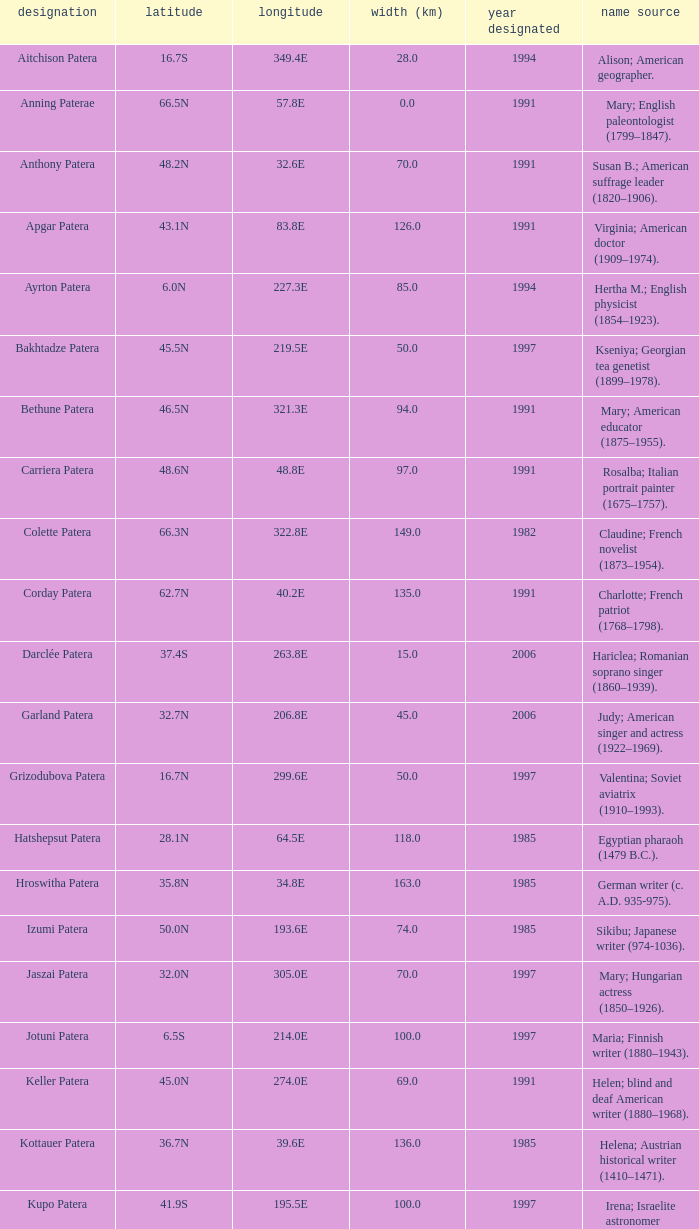Parse the table in full. {'header': ['designation', 'latitude', 'longitude', 'width (km)', 'year designated', 'name source'], 'rows': [['Aitchison Patera', '16.7S', '349.4E', '28.0', '1994', 'Alison; American geographer.'], ['Anning Paterae', '66.5N', '57.8E', '0.0', '1991', 'Mary; English paleontologist (1799–1847).'], ['Anthony Patera', '48.2N', '32.6E', '70.0', '1991', 'Susan B.; American suffrage leader (1820–1906).'], ['Apgar Patera', '43.1N', '83.8E', '126.0', '1991', 'Virginia; American doctor (1909–1974).'], ['Ayrton Patera', '6.0N', '227.3E', '85.0', '1994', 'Hertha M.; English physicist (1854–1923).'], ['Bakhtadze Patera', '45.5N', '219.5E', '50.0', '1997', 'Kseniya; Georgian tea genetist (1899–1978).'], ['Bethune Patera', '46.5N', '321.3E', '94.0', '1991', 'Mary; American educator (1875–1955).'], ['Carriera Patera', '48.6N', '48.8E', '97.0', '1991', 'Rosalba; Italian portrait painter (1675–1757).'], ['Colette Patera', '66.3N', '322.8E', '149.0', '1982', 'Claudine; French novelist (1873–1954).'], ['Corday Patera', '62.7N', '40.2E', '135.0', '1991', 'Charlotte; French patriot (1768–1798).'], ['Darclée Patera', '37.4S', '263.8E', '15.0', '2006', 'Hariclea; Romanian soprano singer (1860–1939).'], ['Garland Patera', '32.7N', '206.8E', '45.0', '2006', 'Judy; American singer and actress (1922–1969).'], ['Grizodubova Patera', '16.7N', '299.6E', '50.0', '1997', 'Valentina; Soviet aviatrix (1910–1993).'], ['Hatshepsut Patera', '28.1N', '64.5E', '118.0', '1985', 'Egyptian pharaoh (1479 B.C.).'], ['Hroswitha Patera', '35.8N', '34.8E', '163.0', '1985', 'German writer (c. A.D. 935-975).'], ['Izumi Patera', '50.0N', '193.6E', '74.0', '1985', 'Sikibu; Japanese writer (974-1036).'], ['Jaszai Patera', '32.0N', '305.0E', '70.0', '1997', 'Mary; Hungarian actress (1850–1926).'], ['Jotuni Patera', '6.5S', '214.0E', '100.0', '1997', 'Maria; Finnish writer (1880–1943).'], ['Keller Patera', '45.0N', '274.0E', '69.0', '1991', 'Helen; blind and deaf American writer (1880–1968).'], ['Kottauer Patera', '36.7N', '39.6E', '136.0', '1985', 'Helena; Austrian historical writer (1410–1471).'], ['Kupo Patera', '41.9S', '195.5E', '100.0', '1997', 'Irena; Israelite astronomer (1929–1978).'], ['Ledoux Patera', '9.2S', '224.8E', '75.0', '1994', 'Jeanne; French artist (1767–1840).'], ['Lindgren Patera', '28.1N', '241.4E', '110.0', '2006', 'Astrid; Swedish author (1907–2002).'], ['Mehseti Patera', '16.0N', '311.0E', '60.0', '1997', 'Ganjevi; Azeri/Persian poet (c. 1050-c. 1100).'], ['Mezrina Patera', '33.3S', '68.8E', '60.0', '2000', 'Anna; Russian clay toy sculptor (1853–1938).'], ['Nordenflycht Patera', '35.0S', '266.0E', '140.0', '1997', 'Hedwig; Swedish poet (1718–1763).'], ['Panina Patera', '13.0S', '309.8E', '50.0', '1997', 'Varya; Gypsy/Russian singer (1872–1911).'], ['Payne-Gaposchkin Patera', '25.5S', '196.0E', '100.0', '1997', 'Cecilia Helena; American astronomer (1900–1979).'], ['Pocahontas Patera', '64.9N', '49.4E', '78.0', '1991', 'Powhatan Indian peacemaker (1595–1617).'], ['Raskova Paterae', '51.0S', '222.8E', '80.0', '1994', 'Marina M.; Russian aviator (1912–1943).'], ['Razia Patera', '46.2N', '197.8E', '157.0', '1985', 'Queen of Delhi Sultanate (India) (1236–1240).'], ['Shulzhenko Patera', '6.5N', '264.5E', '60.0', '1997', 'Klavdiya; Soviet singer (1906–1984).'], ['Siddons Patera', '61.6N', '340.6E', '47.0', '1997', 'Sarah; English actress (1755–1831).'], ['Stopes Patera', '42.6N', '46.5E', '169.0', '1991', 'Marie; English paleontologist (1880–1959).'], ['Tarbell Patera', '58.2S', '351.5E', '80.0', '1994', 'Ida; American author, editor (1857–1944).'], ['Teasdale Patera', '67.6S', '189.1E', '75.0', '1994', 'Sara; American poet (1884–1933).'], ['Tey Patera', '17.8S', '349.1E', '20.0', '1994', 'Josephine; Scottish author (1897–1952).'], ['Tipporah Patera', '38.9N', '43.0E', '99.0', '1985', 'Hebrew medical scholar (1500 B.C.).'], ['Vibert-Douglas Patera', '11.6S', '194.3E', '45.0', '2003', 'Allie; Canadian astronomer (1894–1988).'], ['Villepreux-Power Patera', '22.0S', '210.0E', '100.0', '1997', 'Jeannette; French marine biologist (1794–1871).'], ['Wilde Patera', '21.3S', '266.3E', '75.0', '2000', 'Lady Jane Francesca; Irish poet (1821–1891).'], ['Witte Patera', '25.8S', '247.65E', '35.0', '2006', 'Wilhelmine; German astronomer (1777–1854).'], ['Woodhull Patera', '37.4N', '305.4E', '83.0', '1991', 'Victoria; American-English lecturer (1838–1927).']]} What is the longitude of the feature named Razia Patera?  197.8E. 